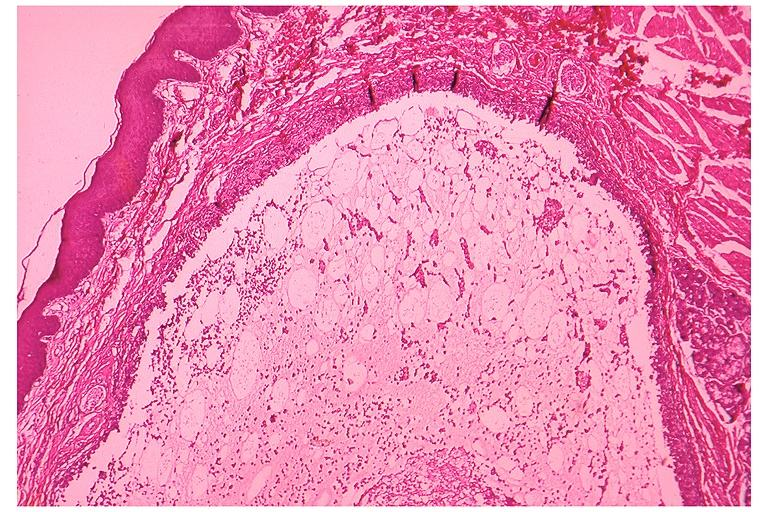s metastatic carcinoid present?
Answer the question using a single word or phrase. No 